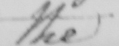What does this handwritten line say? the 